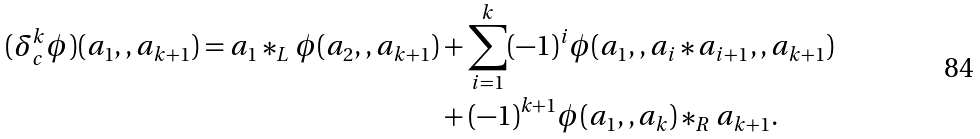<formula> <loc_0><loc_0><loc_500><loc_500>( \delta _ { c } ^ { k } \phi ) ( a _ { 1 } , , a _ { k + 1 } ) = a _ { 1 } * _ { L } \phi ( a _ { 2 } , , a _ { k + 1 } ) & + \sum _ { i = 1 } ^ { k } ( - 1 ) ^ { i } \phi ( a _ { 1 } , , a _ { i } * a _ { i + 1 } , , a _ { k + 1 } ) \\ & + ( - 1 ) ^ { k + 1 } \phi ( a _ { 1 } , , a _ { k } ) * _ { R } a _ { k + 1 } .</formula> 